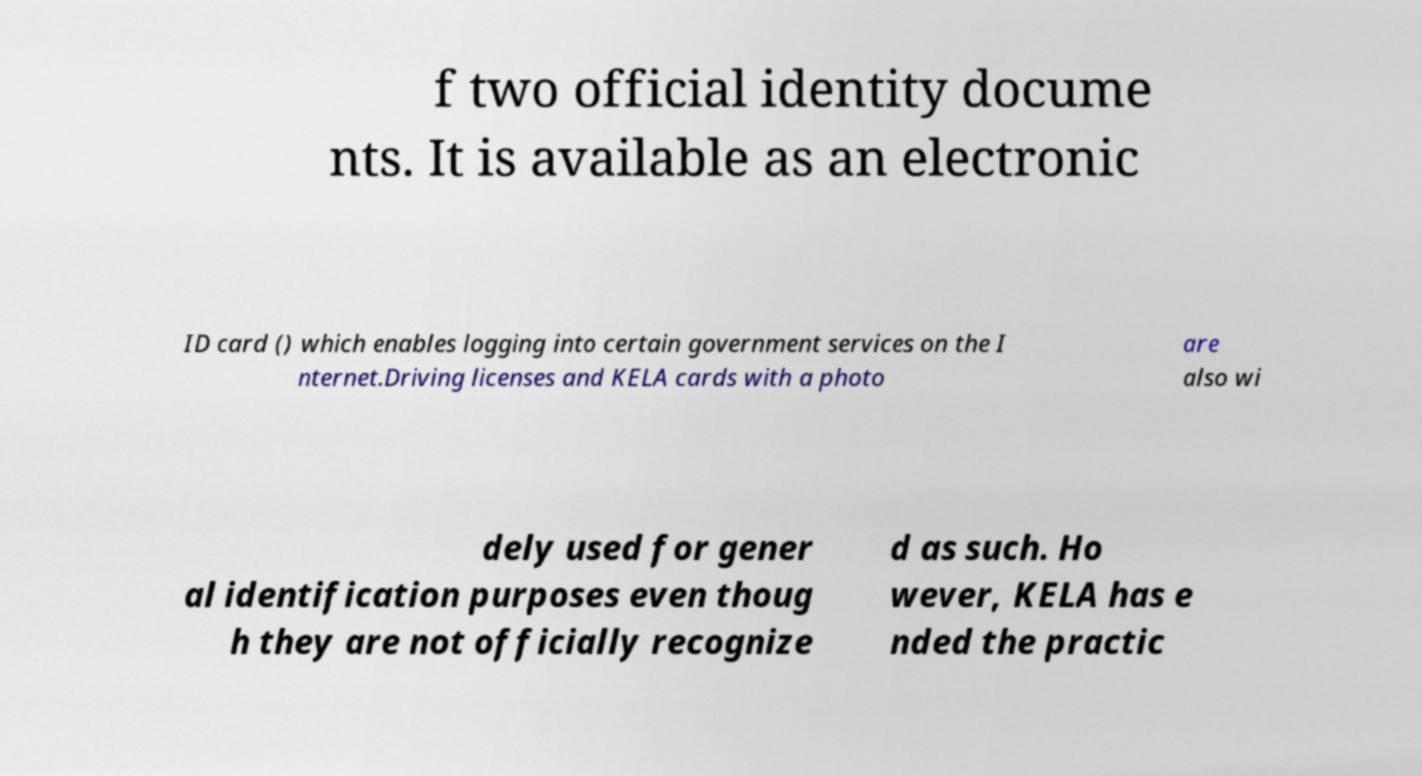Can you accurately transcribe the text from the provided image for me? f two official identity docume nts. It is available as an electronic ID card () which enables logging into certain government services on the I nternet.Driving licenses and KELA cards with a photo are also wi dely used for gener al identification purposes even thoug h they are not officially recognize d as such. Ho wever, KELA has e nded the practic 